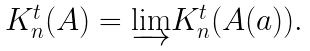Convert formula to latex. <formula><loc_0><loc_0><loc_500><loc_500>\begin{array} { c } { K } _ { n } ^ { t } ( A ) = \underrightarrow { \lim } K _ { n } ^ { t } ( A ( a ) ) . \end{array}</formula> 